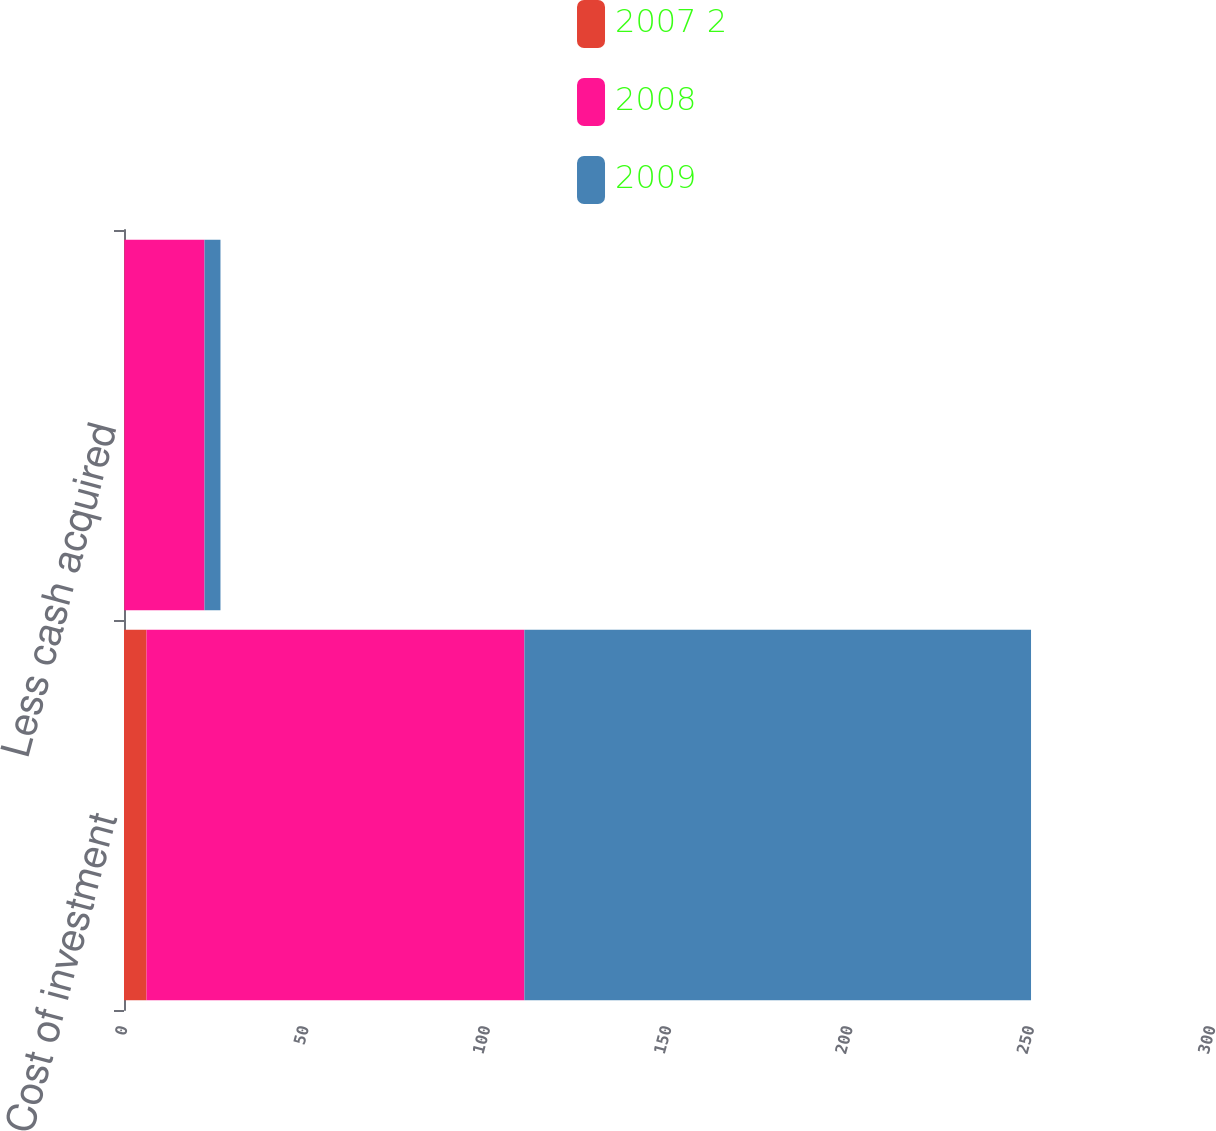Convert chart to OTSL. <chart><loc_0><loc_0><loc_500><loc_500><stacked_bar_chart><ecel><fcel>Cost of investment<fcel>Less cash acquired<nl><fcel>2007 2<fcel>6.2<fcel>0.1<nl><fcel>2008<fcel>104.2<fcel>22.1<nl><fcel>2009<fcel>139.7<fcel>4.4<nl></chart> 